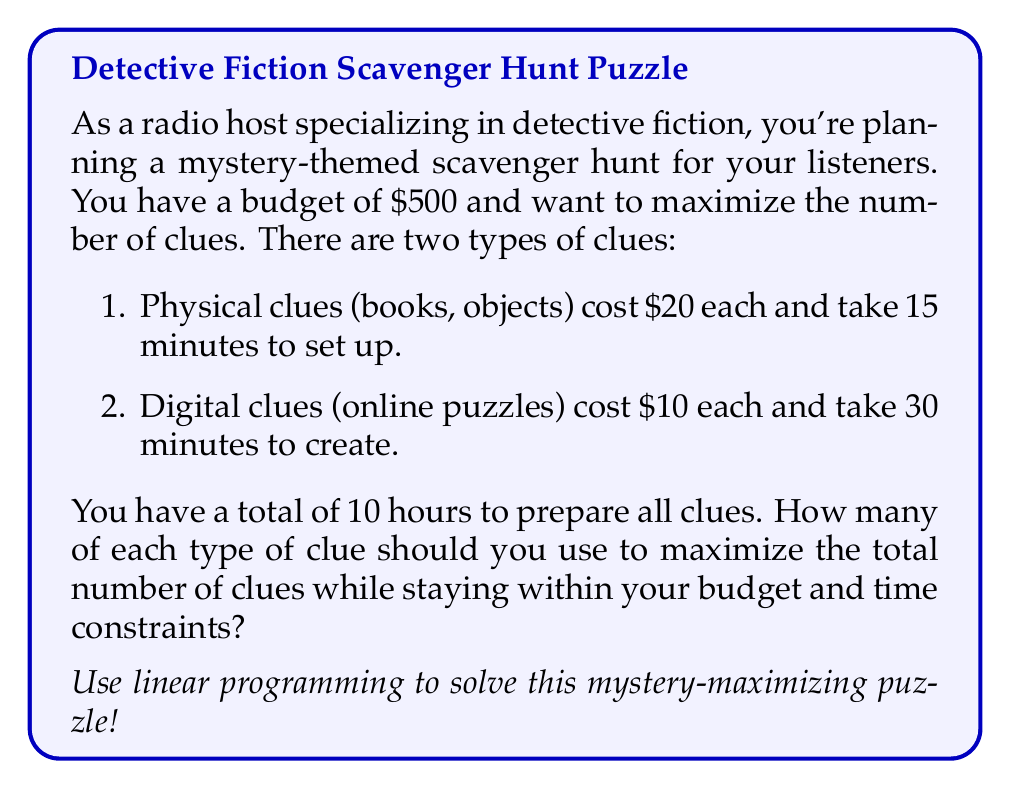Can you solve this math problem? Let's approach this problem step-by-step using linear programming:

1. Define variables:
   Let $x$ = number of physical clues
   Let $y$ = number of digital clues

2. Objective function:
   We want to maximize the total number of clues, so our objective function is:
   Maximize $z = x + y$

3. Constraints:
   a) Budget constraint: $20x + 10y \leq 500$
   b) Time constraint: $15x + 30y \leq 600$ (10 hours = 600 minutes)
   c) Non-negativity: $x \geq 0, y \geq 0$

4. Solve graphically:
   Plot the constraints on a coordinate system:

   [asy]
   import geometry;
   
   size(200);
   
   xaxis("Physical clues (x)", 0, 35, Arrow);
   yaxis("Digital clues (y)", 0, 35, Arrow);
   
   draw((0,50)--(25,0), blue);
   draw((0,20)--(40,0), red);
   
   label("Budget constraint", (15,15), E, blue);
   label("Time constraint", (25,5), N, red);
   
   fill((0,0)--(0,20)--(25,0)--cycle, lightgray);
   
   dot((0,20));
   dot((25,0));
   dot((20,10));
   
   label("(0,20)", (0,20), W);
   label("(25,0)", (25,0), S);
   label("(20,10)", (20,10), NE);
   [/asy]

5. Find the optimal solution:
   The feasible region is the shaded area. The optimal solution will be at one of the corner points:
   (0,0), (0,20), (25,0), or (20,10)

   Evaluate the objective function at each point:
   (0,0): z = 0
   (0,20): z = 20
   (25,0): z = 25
   (20,10): z = 30

   The maximum value occurs at (20,10).

Therefore, the optimal solution is to use 20 physical clues and 10 digital clues, for a total of 30 clues.

6. Verify constraints:
   Budget: $20(20) + 10(10) = 500$ (exactly at budget)
   Time: $15(20) + 30(10) = 600$ minutes (exactly at time limit)

This solution maximizes the number of clues while staying within all constraints.
Answer: The optimal solution is to use 20 physical clues and 10 digital clues, for a total of 30 clues. 